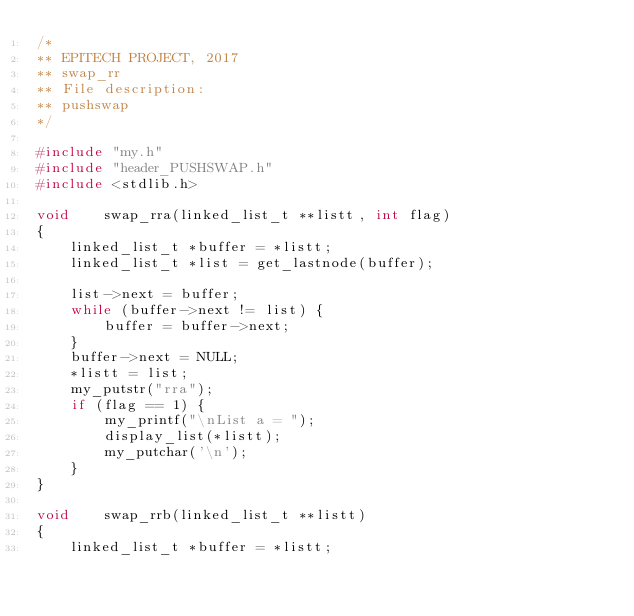Convert code to text. <code><loc_0><loc_0><loc_500><loc_500><_C_>/*
** EPITECH PROJECT, 2017
** swap_rr
** File description:
** pushswap
*/

#include "my.h"
#include "header_PUSHSWAP.h"
#include <stdlib.h>

void    swap_rra(linked_list_t **listt, int flag)
{
	linked_list_t *buffer = *listt;
	linked_list_t *list = get_lastnode(buffer);

	list->next = buffer;
	while (buffer->next != list) {
		buffer = buffer->next;
	}
	buffer->next = NULL;
	*listt = list;
	my_putstr("rra");
	if (flag == 1) {
		my_printf("\nList a = ");
		display_list(*listt);
		my_putchar('\n');
	}
}

void    swap_rrb(linked_list_t **listt)
{
	linked_list_t *buffer = *listt;</code> 